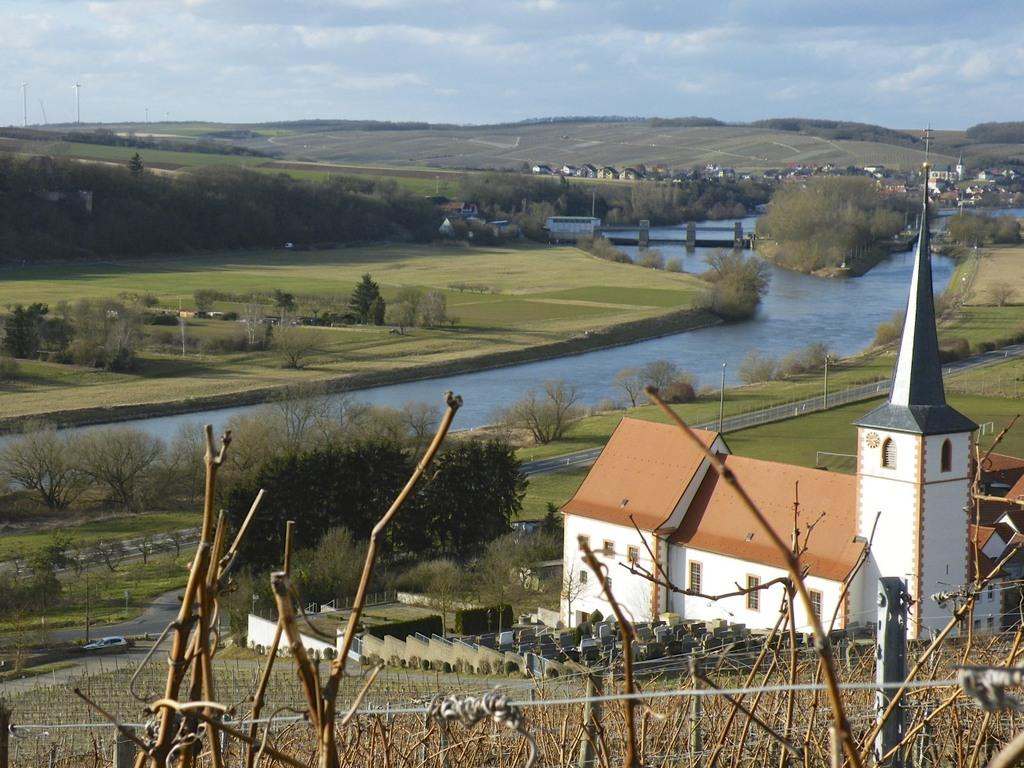What can be seen in the sky in the image? The sky with clouds is visible in the image. What type of natural landform is present in the image? There are hills in the image. What type of man-made structures can be seen in the image? There are buildings in the image. What type of infrastructure is present in the image? A bridge is present in the image. What is the ground like in the image? The ground is visible in the image. What type of vegetation is present in the image? Trees are present in the image. What type of water body is present in the image? There is a river in the image. What type of vertical structures are visible in the image? Street poles are visible in the image. What type of transportation infrastructure is present in the image? A road is present in the image. What type of barrier is visible in the image? A fence is visible in the image. What type of linen is draped over the bridge in the image? There is no linen present in the image, and the bridge is not draped with any fabric. What type of amusement can be seen in the image? There is no amusement park or any amusement-related activity depicted in the image. 